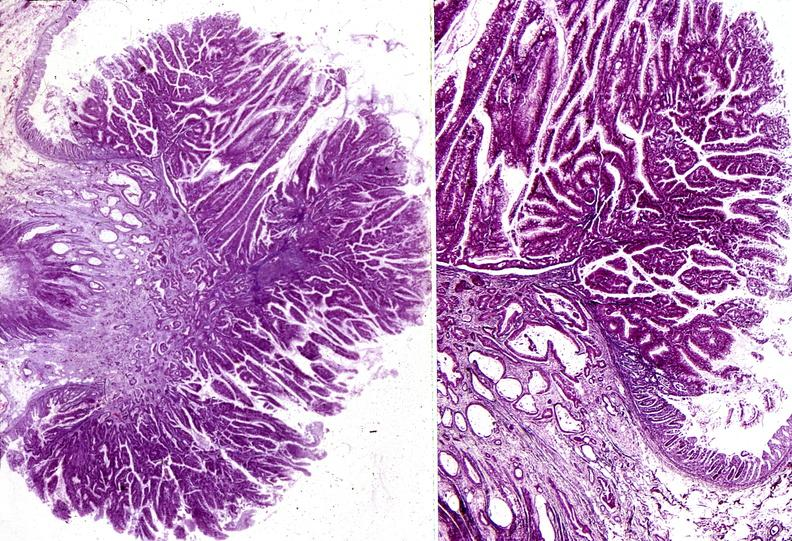what is present?
Answer the question using a single word or phrase. Gastrointestinal 